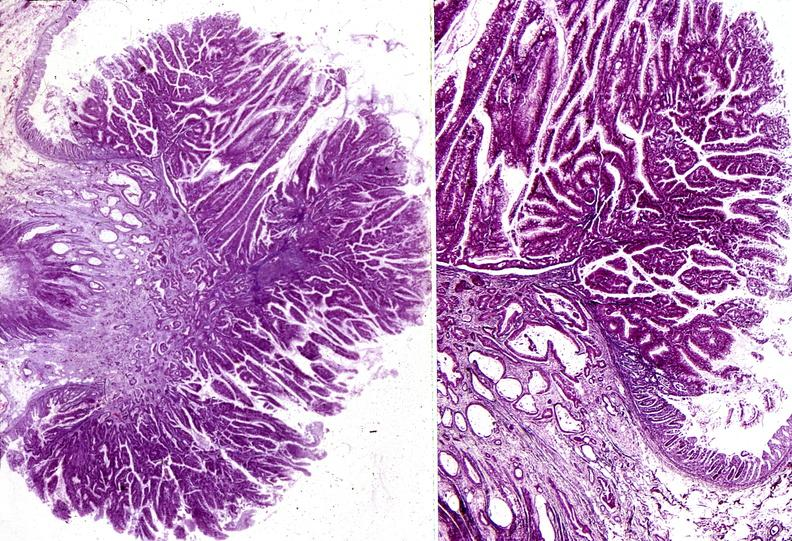what is present?
Answer the question using a single word or phrase. Gastrointestinal 